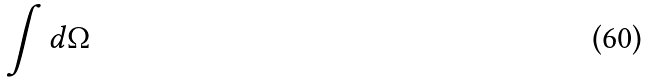Convert formula to latex. <formula><loc_0><loc_0><loc_500><loc_500>\int d \Omega</formula> 